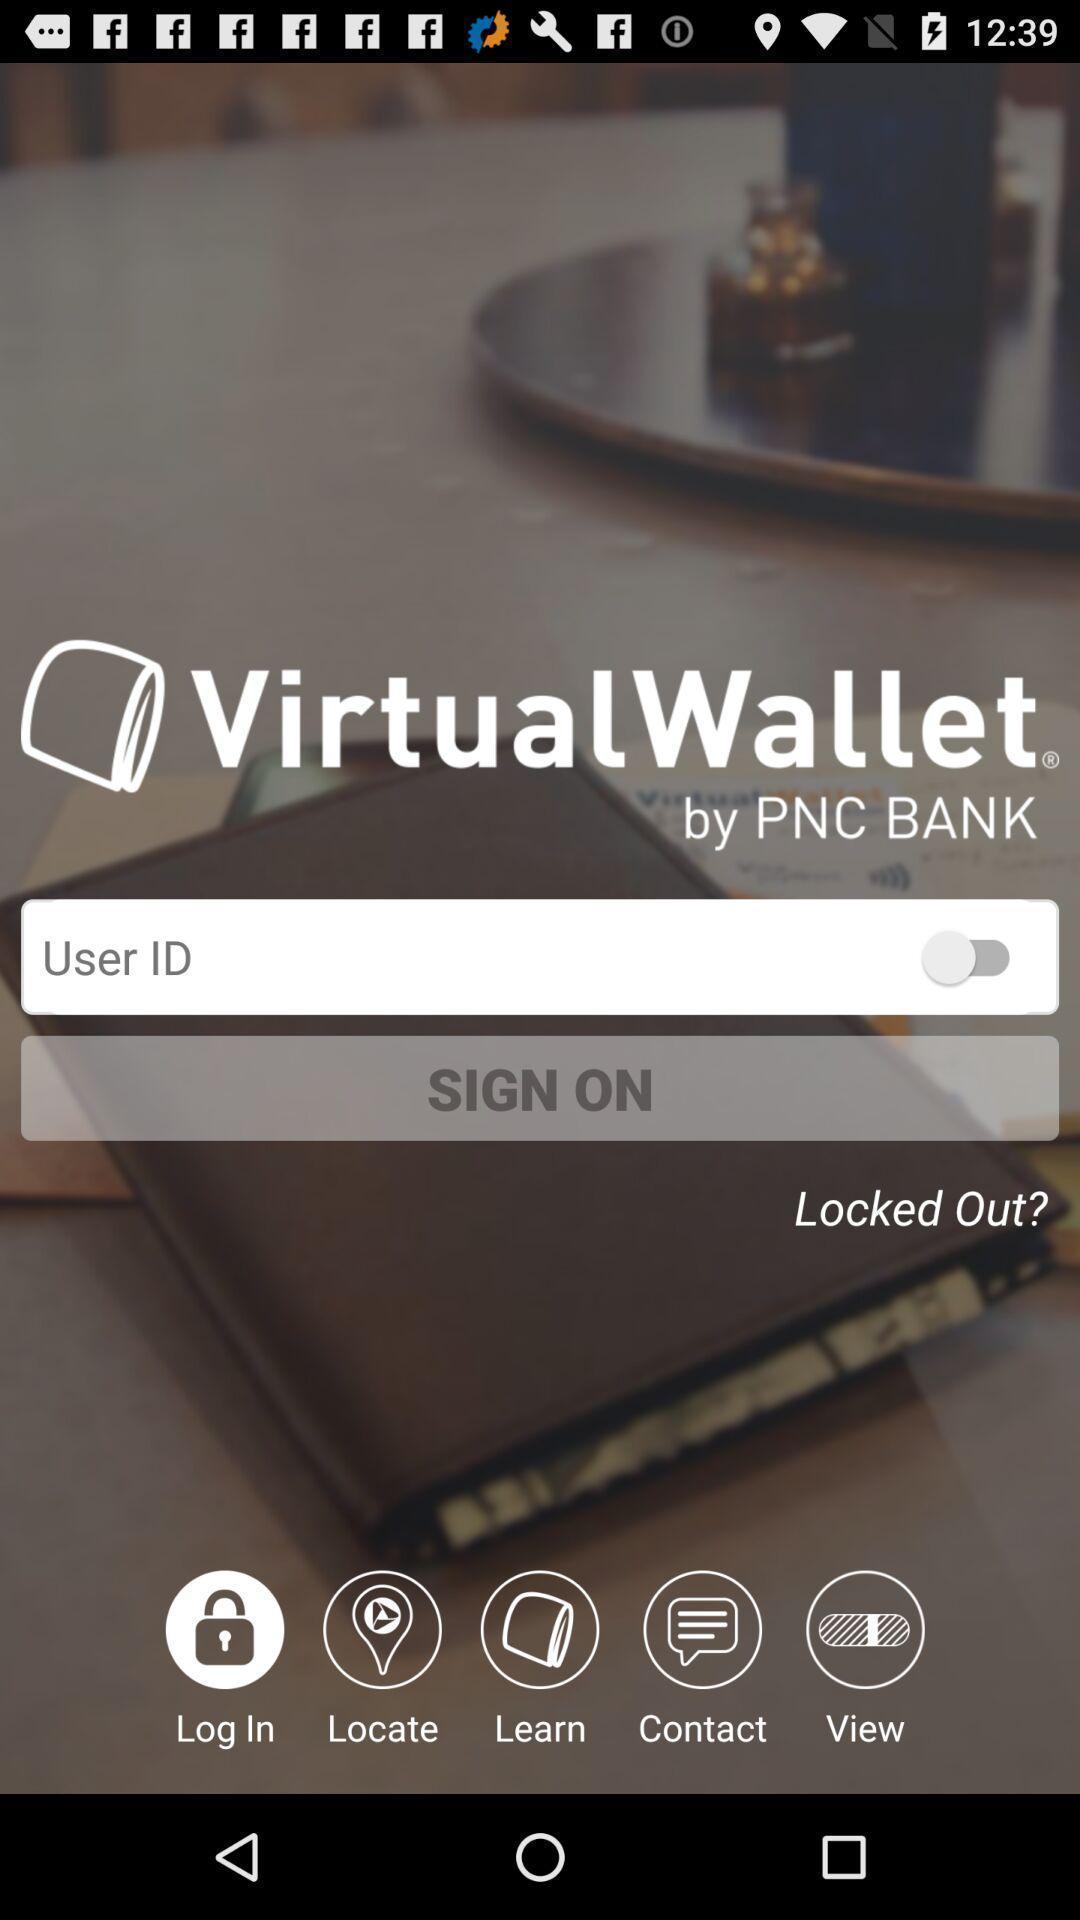Summarize the main components in this picture. Sign on page for a wallet app. 